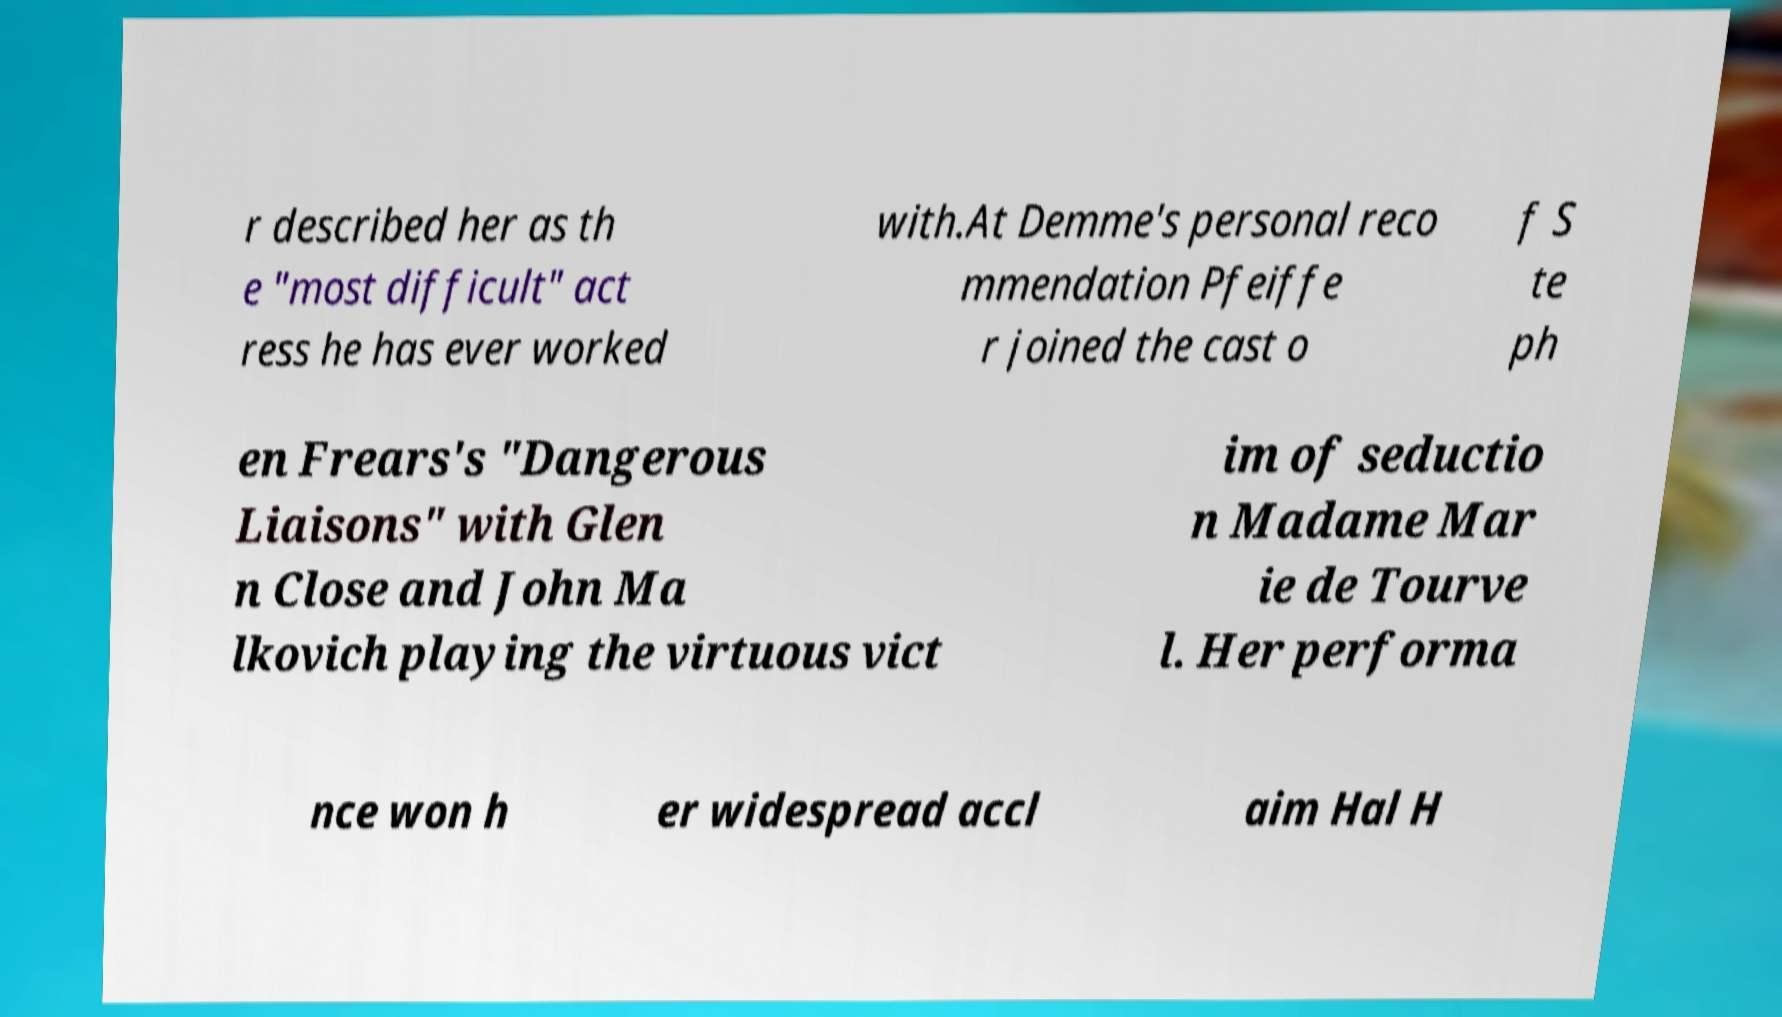Please identify and transcribe the text found in this image. r described her as th e "most difficult" act ress he has ever worked with.At Demme's personal reco mmendation Pfeiffe r joined the cast o f S te ph en Frears's "Dangerous Liaisons" with Glen n Close and John Ma lkovich playing the virtuous vict im of seductio n Madame Mar ie de Tourve l. Her performa nce won h er widespread accl aim Hal H 